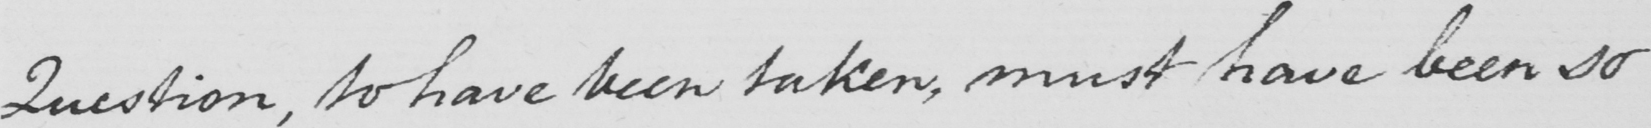What text is written in this handwritten line? Question , to have been taken , must have been so 